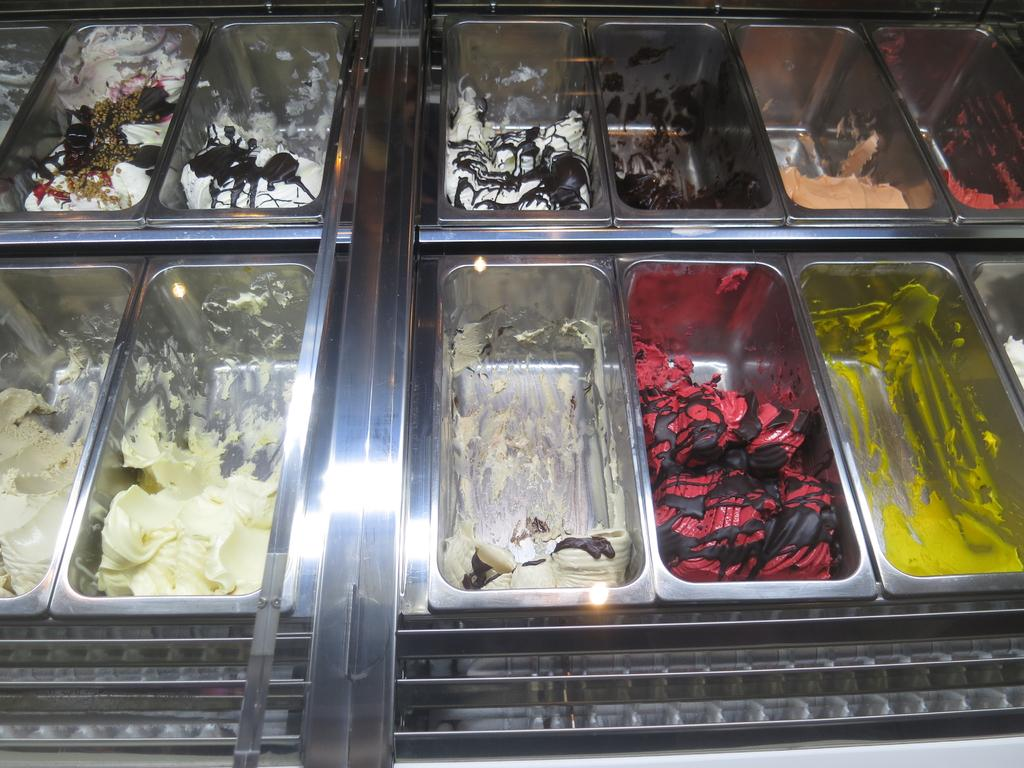What objects are present in the image? There are containers in the image. What are the containers used for? The containers hold creams. Is there a sofa made of cream in the image? No, there is no sofa made of cream in the image. The image only contains containers holding creams. 